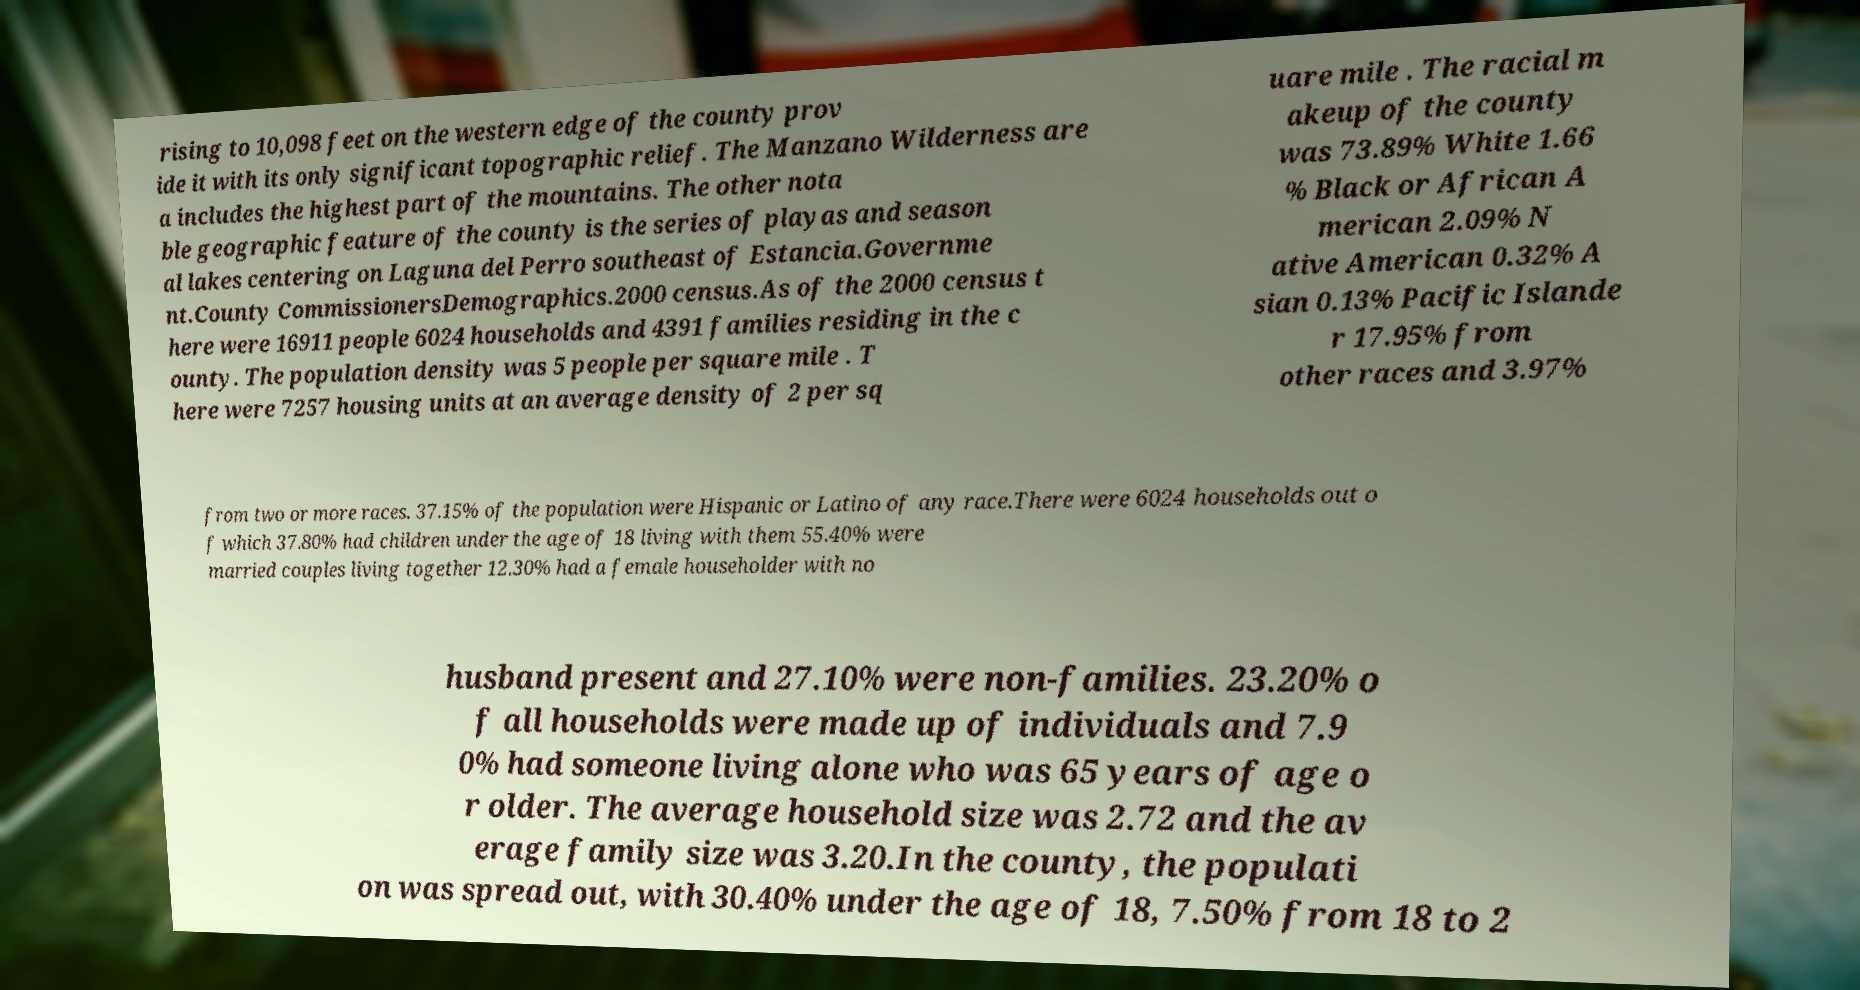I need the written content from this picture converted into text. Can you do that? rising to 10,098 feet on the western edge of the county prov ide it with its only significant topographic relief. The Manzano Wilderness are a includes the highest part of the mountains. The other nota ble geographic feature of the county is the series of playas and season al lakes centering on Laguna del Perro southeast of Estancia.Governme nt.County CommissionersDemographics.2000 census.As of the 2000 census t here were 16911 people 6024 households and 4391 families residing in the c ounty. The population density was 5 people per square mile . T here were 7257 housing units at an average density of 2 per sq uare mile . The racial m akeup of the county was 73.89% White 1.66 % Black or African A merican 2.09% N ative American 0.32% A sian 0.13% Pacific Islande r 17.95% from other races and 3.97% from two or more races. 37.15% of the population were Hispanic or Latino of any race.There were 6024 households out o f which 37.80% had children under the age of 18 living with them 55.40% were married couples living together 12.30% had a female householder with no husband present and 27.10% were non-families. 23.20% o f all households were made up of individuals and 7.9 0% had someone living alone who was 65 years of age o r older. The average household size was 2.72 and the av erage family size was 3.20.In the county, the populati on was spread out, with 30.40% under the age of 18, 7.50% from 18 to 2 